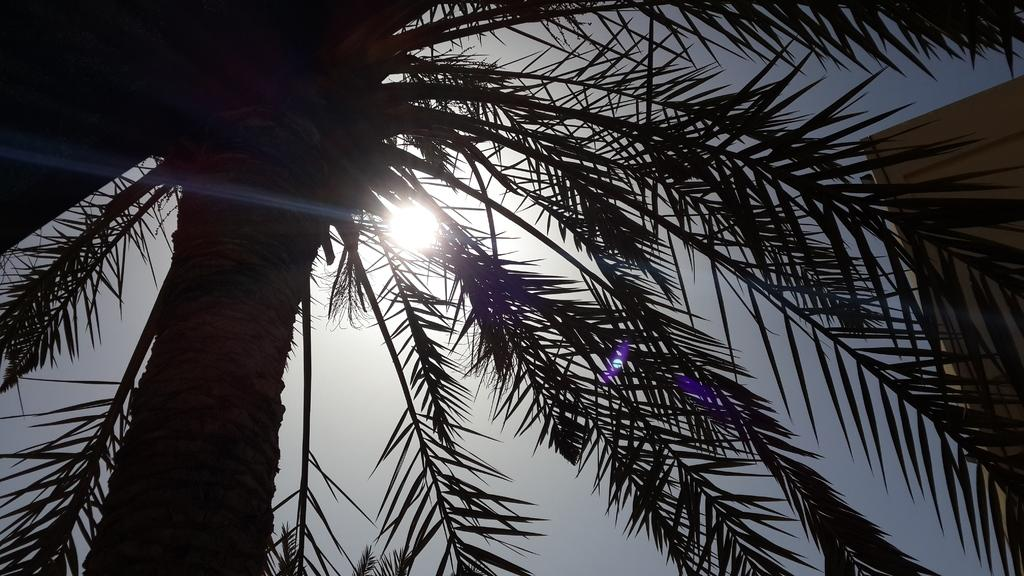What is located on the left side of the image? There is a tree on the left side of the image. What celestial body can be seen in the sky in the image? The sun is visible in the sky in the image. What type of veil is draped over the tree in the image? There is no veil present in the image; it only features a tree and the sun in the sky. 